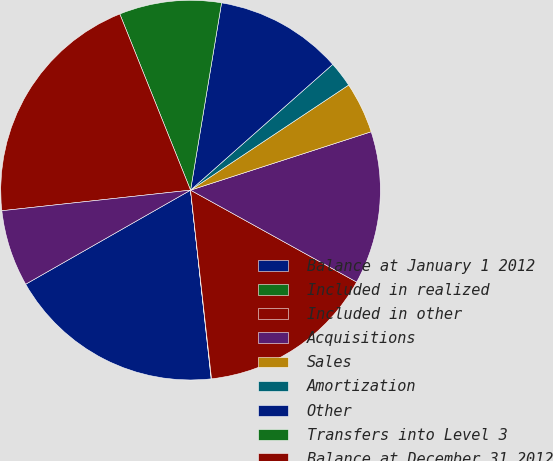<chart> <loc_0><loc_0><loc_500><loc_500><pie_chart><fcel>Balance at January 1 2012<fcel>Included in realized<fcel>Included in other<fcel>Acquisitions<fcel>Sales<fcel>Amortization<fcel>Other<fcel>Transfers into Level 3<fcel>Balance at December 31 2012<fcel>Transfers out of Level 3<nl><fcel>18.48%<fcel>0.03%<fcel>15.19%<fcel>13.02%<fcel>4.36%<fcel>2.19%<fcel>10.86%<fcel>8.69%<fcel>20.65%<fcel>6.52%<nl></chart> 